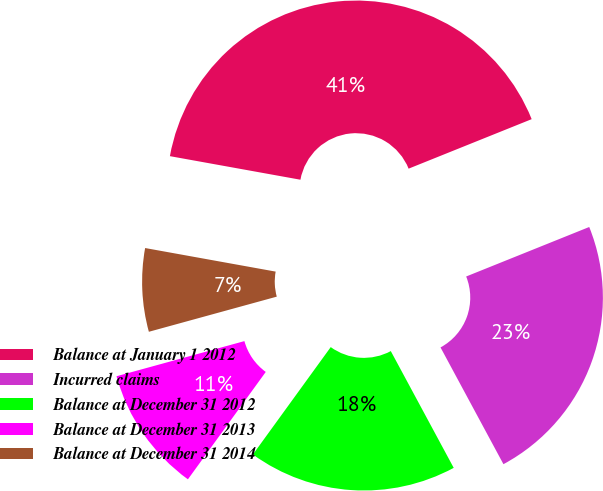Convert chart to OTSL. <chart><loc_0><loc_0><loc_500><loc_500><pie_chart><fcel>Balance at January 1 2012<fcel>Incurred claims<fcel>Balance at December 31 2012<fcel>Balance at December 31 2013<fcel>Balance at December 31 2014<nl><fcel>41.07%<fcel>23.22%<fcel>17.85%<fcel>10.75%<fcel>7.11%<nl></chart> 